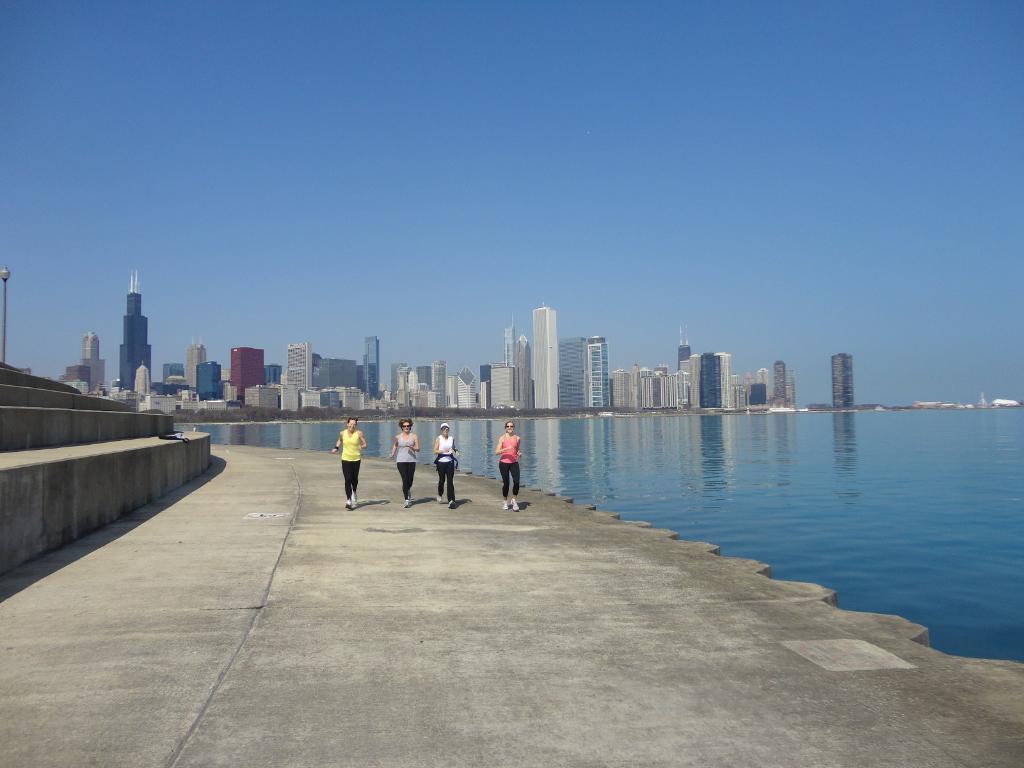How would you summarize this image in a sentence or two? In this image in the center there are persons running. On the right side there is water. In the background there are buildings, on the left side there are steps and there is a pole. 